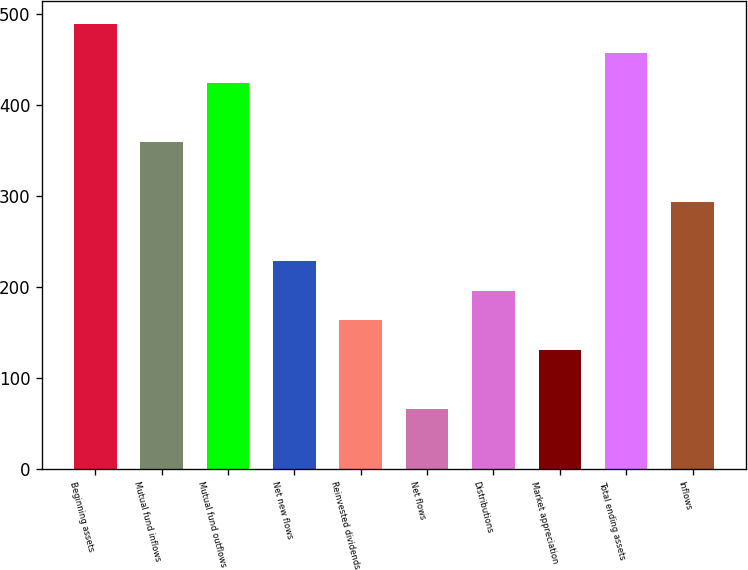<chart> <loc_0><loc_0><loc_500><loc_500><bar_chart><fcel>Beginning assets<fcel>Mutual fund inflows<fcel>Mutual fund outflows<fcel>Net new flows<fcel>Reinvested dividends<fcel>Net flows<fcel>Distributions<fcel>Market appreciation<fcel>Total ending assets<fcel>Inflows<nl><fcel>489.1<fcel>358.7<fcel>423.9<fcel>228.3<fcel>163.1<fcel>65.3<fcel>195.7<fcel>130.5<fcel>456.5<fcel>293.5<nl></chart> 